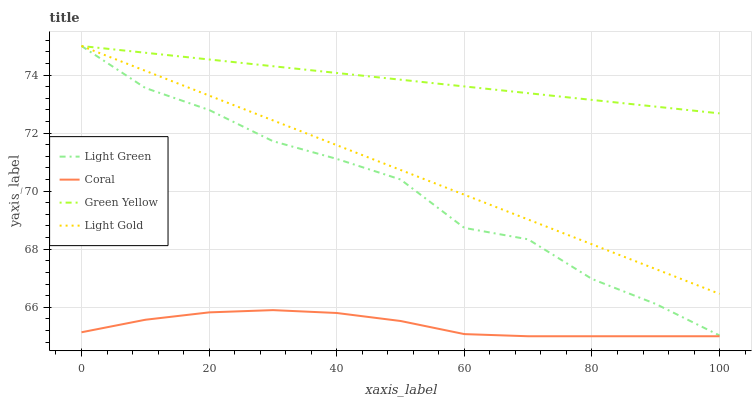Does Coral have the minimum area under the curve?
Answer yes or no. Yes. Does Green Yellow have the maximum area under the curve?
Answer yes or no. Yes. Does Light Gold have the minimum area under the curve?
Answer yes or no. No. Does Light Gold have the maximum area under the curve?
Answer yes or no. No. Is Light Gold the smoothest?
Answer yes or no. Yes. Is Light Green the roughest?
Answer yes or no. Yes. Is Green Yellow the smoothest?
Answer yes or no. No. Is Green Yellow the roughest?
Answer yes or no. No. Does Coral have the lowest value?
Answer yes or no. Yes. Does Light Gold have the lowest value?
Answer yes or no. No. Does Light Green have the highest value?
Answer yes or no. Yes. Is Coral less than Light Gold?
Answer yes or no. Yes. Is Light Green greater than Coral?
Answer yes or no. Yes. Does Green Yellow intersect Light Green?
Answer yes or no. Yes. Is Green Yellow less than Light Green?
Answer yes or no. No. Is Green Yellow greater than Light Green?
Answer yes or no. No. Does Coral intersect Light Gold?
Answer yes or no. No. 